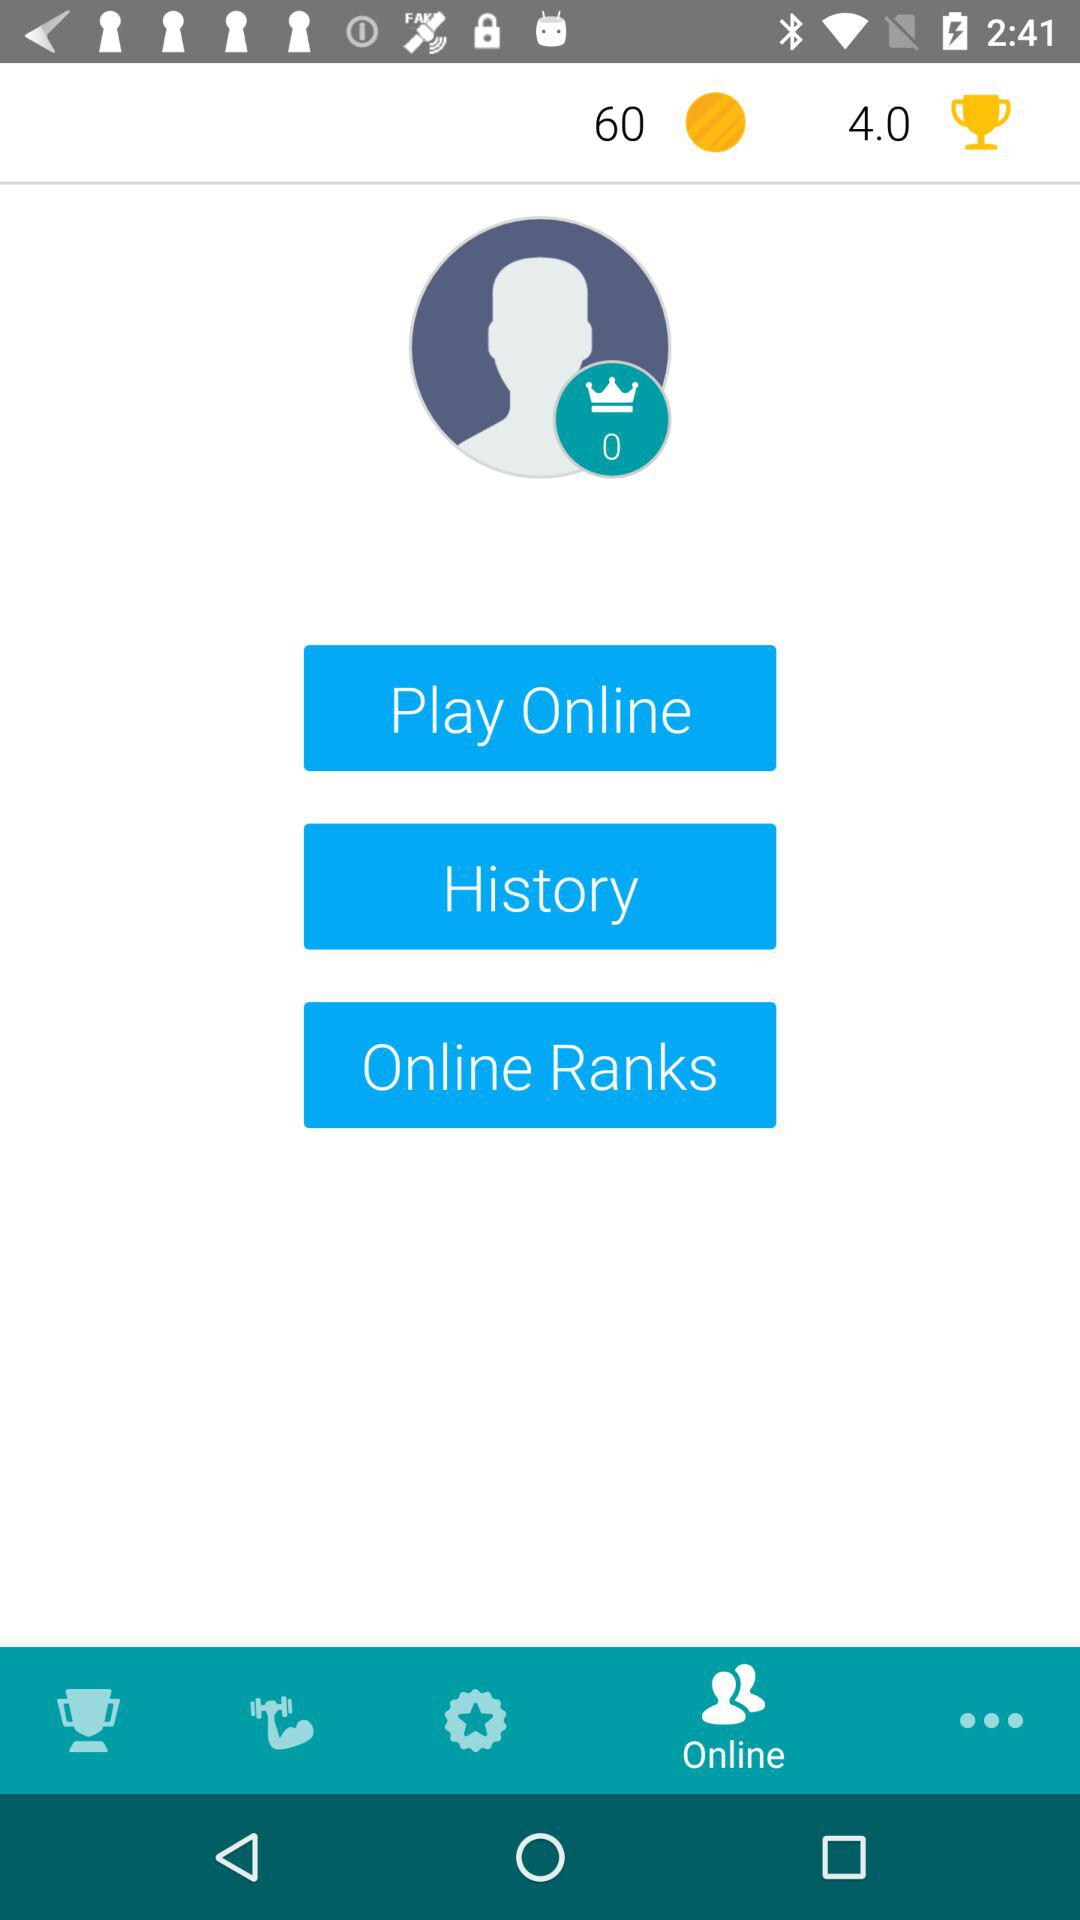Which tab is selected? The selected tab is "Online". 